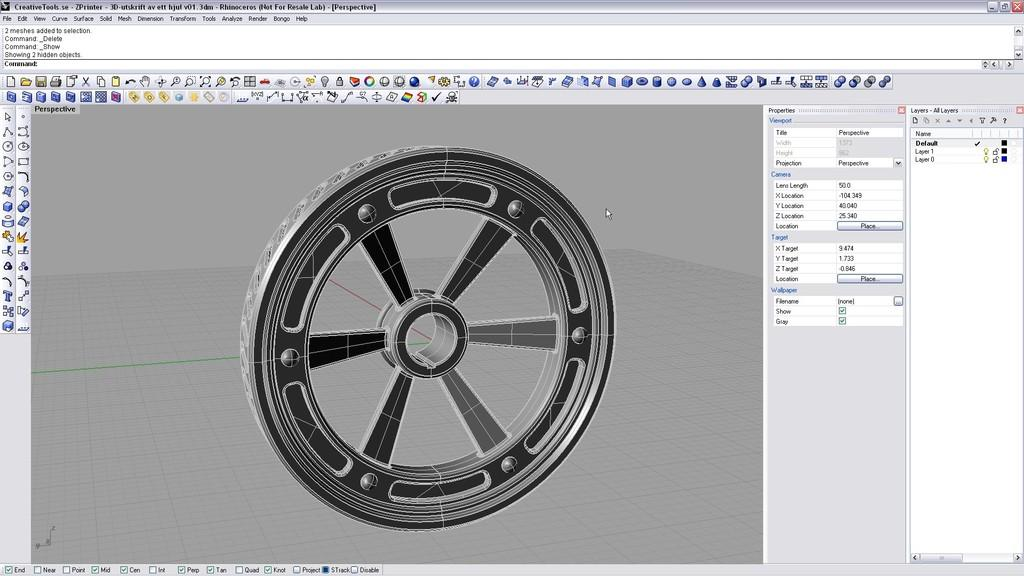What type of device is shown in the image? The image is a screenshot of a computer. What is the main feature in the middle of the screenshot? There is a wheel in the middle of the screenshot. What is located above the wheel in the screenshot? There is a toolbar above the wheel in the screenshot. How many crows are sitting on the linen in the image? There are no crows or linen present in the image; it is a screenshot of a computer with a wheel and a toolbar. 